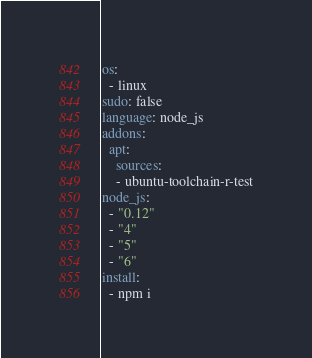<code> <loc_0><loc_0><loc_500><loc_500><_YAML_>os:
  - linux
sudo: false
language: node_js
addons:
  apt:
    sources:
    - ubuntu-toolchain-r-test
node_js:
  - "0.12"
  - "4"
  - "5"
  - "6"
install:
  - npm i 
</code> 